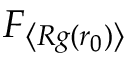Convert formula to latex. <formula><loc_0><loc_0><loc_500><loc_500>F _ { \left \langle R g ( r _ { 0 } ) \right \rangle }</formula> 